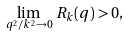<formula> <loc_0><loc_0><loc_500><loc_500>\lim _ { q ^ { 2 } / k ^ { 2 } \to 0 } \, R _ { k } ( q ) > 0 ,</formula> 